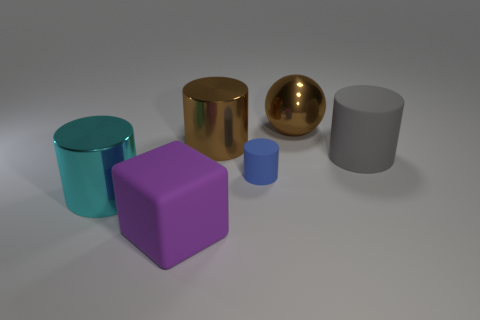Do the ball and the big metal cylinder on the right side of the purple block have the same color?
Give a very brief answer. Yes. There is a thing to the right of the brown metallic thing that is right of the small blue thing; what is its color?
Your response must be concise. Gray. Is there a cyan thing right of the brown metal thing right of the large brown thing that is to the left of the blue rubber thing?
Offer a terse response. No. The cylinder that is the same material as the large cyan thing is what color?
Offer a terse response. Brown. How many other big objects have the same material as the big purple object?
Make the answer very short. 1. Is the purple object made of the same material as the large cylinder to the right of the big brown metal cylinder?
Keep it short and to the point. Yes. What number of things are brown things that are behind the big brown cylinder or cyan things?
Give a very brief answer. 2. What size is the matte cylinder that is on the left side of the sphere that is left of the matte thing behind the tiny blue cylinder?
Provide a short and direct response. Small. There is a cylinder that is the same color as the ball; what material is it?
Your response must be concise. Metal. Are there any other things that have the same shape as the big purple rubber object?
Keep it short and to the point. No. 